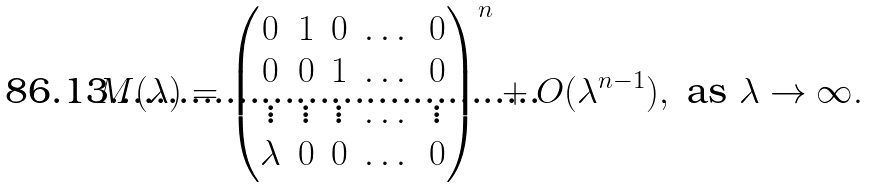Convert formula to latex. <formula><loc_0><loc_0><loc_500><loc_500>M ( \lambda ) = \begin{pmatrix} 0 & 1 & 0 & \dots & 0 \\ 0 & 0 & 1 & \dots & 0 \\ \vdots & \vdots & \vdots & \dots & \vdots \\ \lambda & 0 & 0 & \dots & 0 \end{pmatrix} ^ { n } + O ( \lambda ^ { n - 1 } ) , \text { as } \lambda \to \infty .</formula> 